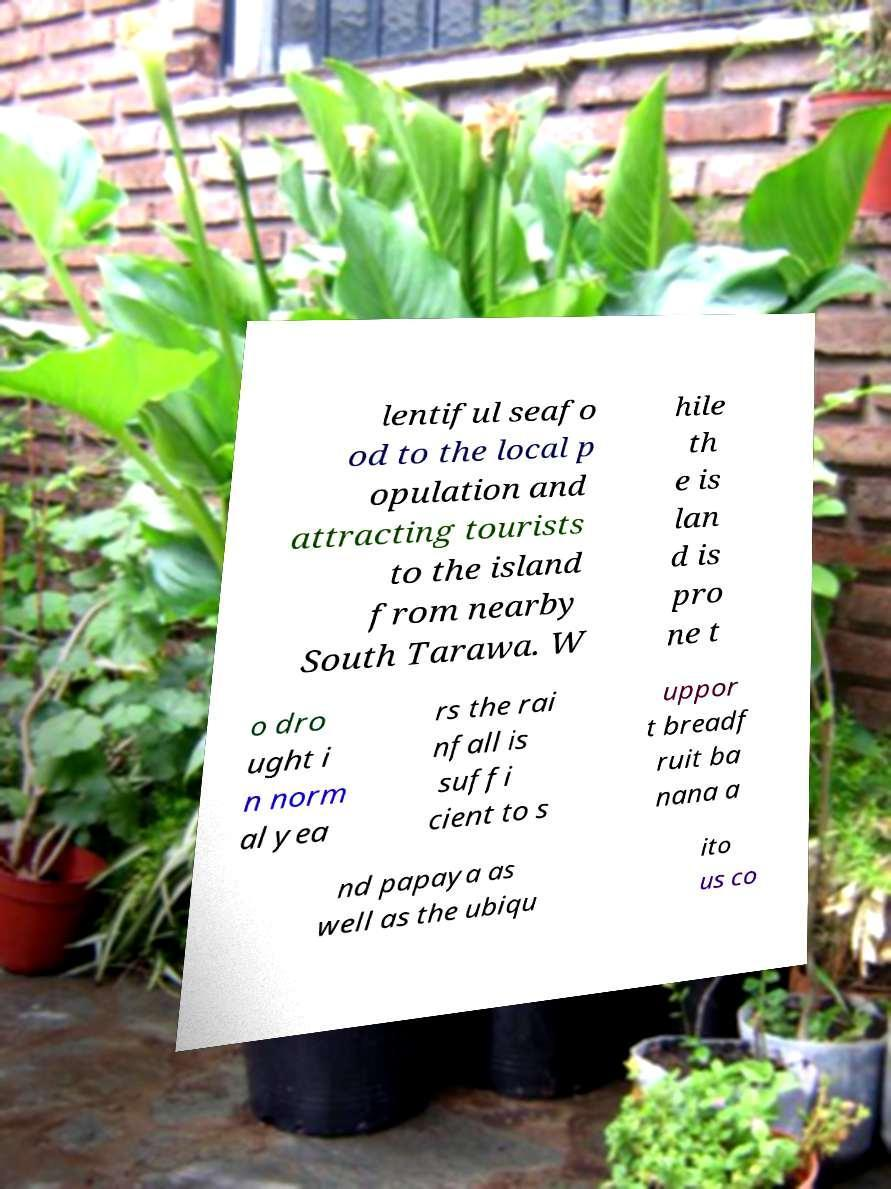Could you assist in decoding the text presented in this image and type it out clearly? lentiful seafo od to the local p opulation and attracting tourists to the island from nearby South Tarawa. W hile th e is lan d is pro ne t o dro ught i n norm al yea rs the rai nfall is suffi cient to s uppor t breadf ruit ba nana a nd papaya as well as the ubiqu ito us co 